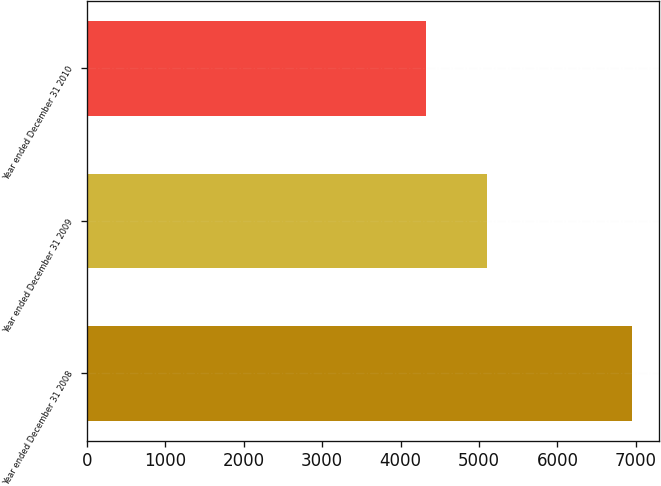Convert chart. <chart><loc_0><loc_0><loc_500><loc_500><bar_chart><fcel>Year ended December 31 2008<fcel>Year ended December 31 2009<fcel>Year ended December 31 2010<nl><fcel>6948<fcel>5102<fcel>4326<nl></chart> 